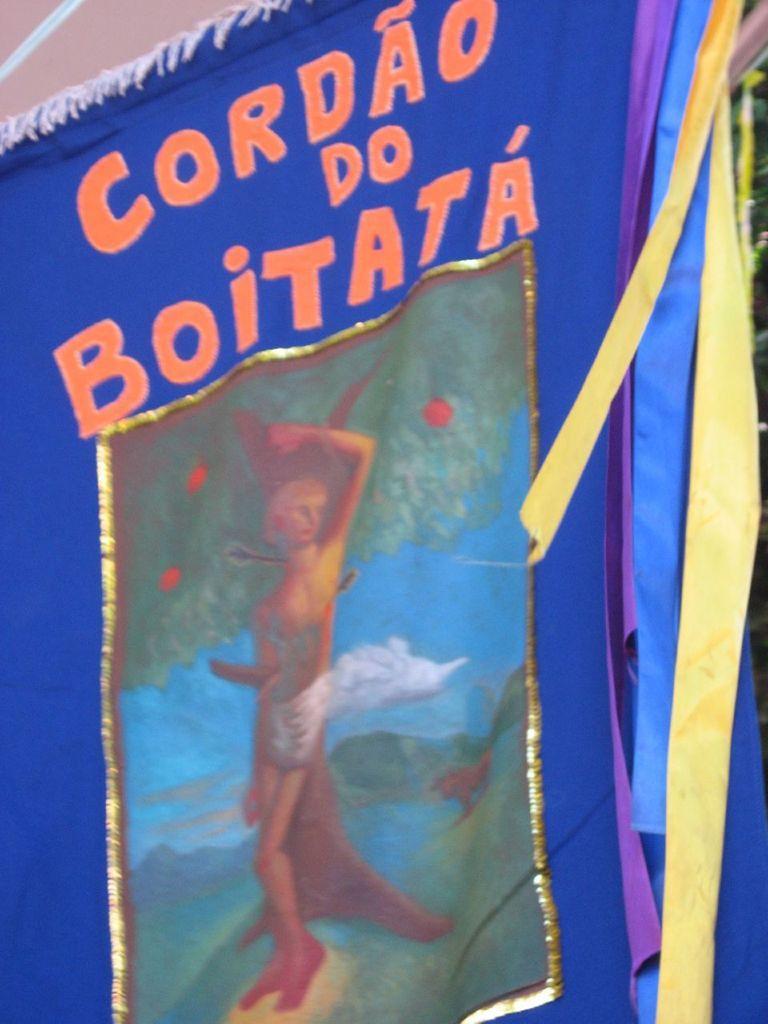Can you describe this image briefly? In this image I can see a cloth which is blue and orange in color and on it I can see a picture of a person , few trees, the sky and few fruits. I can see few other clothes which are yellow and purple in color to the right side of the image. 